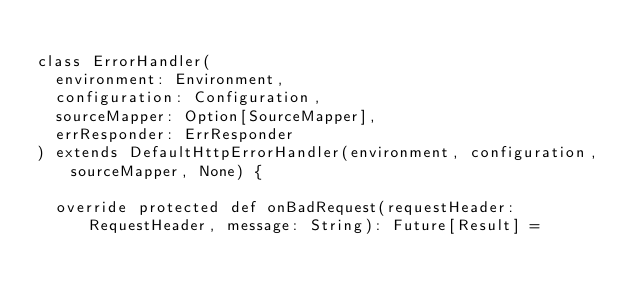<code> <loc_0><loc_0><loc_500><loc_500><_Scala_>
class ErrorHandler(
  environment: Environment,
  configuration: Configuration,
  sourceMapper: Option[SourceMapper],
  errResponder: ErrResponder
) extends DefaultHttpErrorHandler(environment, configuration, sourceMapper, None) {

  override protected def onBadRequest(requestHeader: RequestHeader, message: String): Future[Result] =</code> 